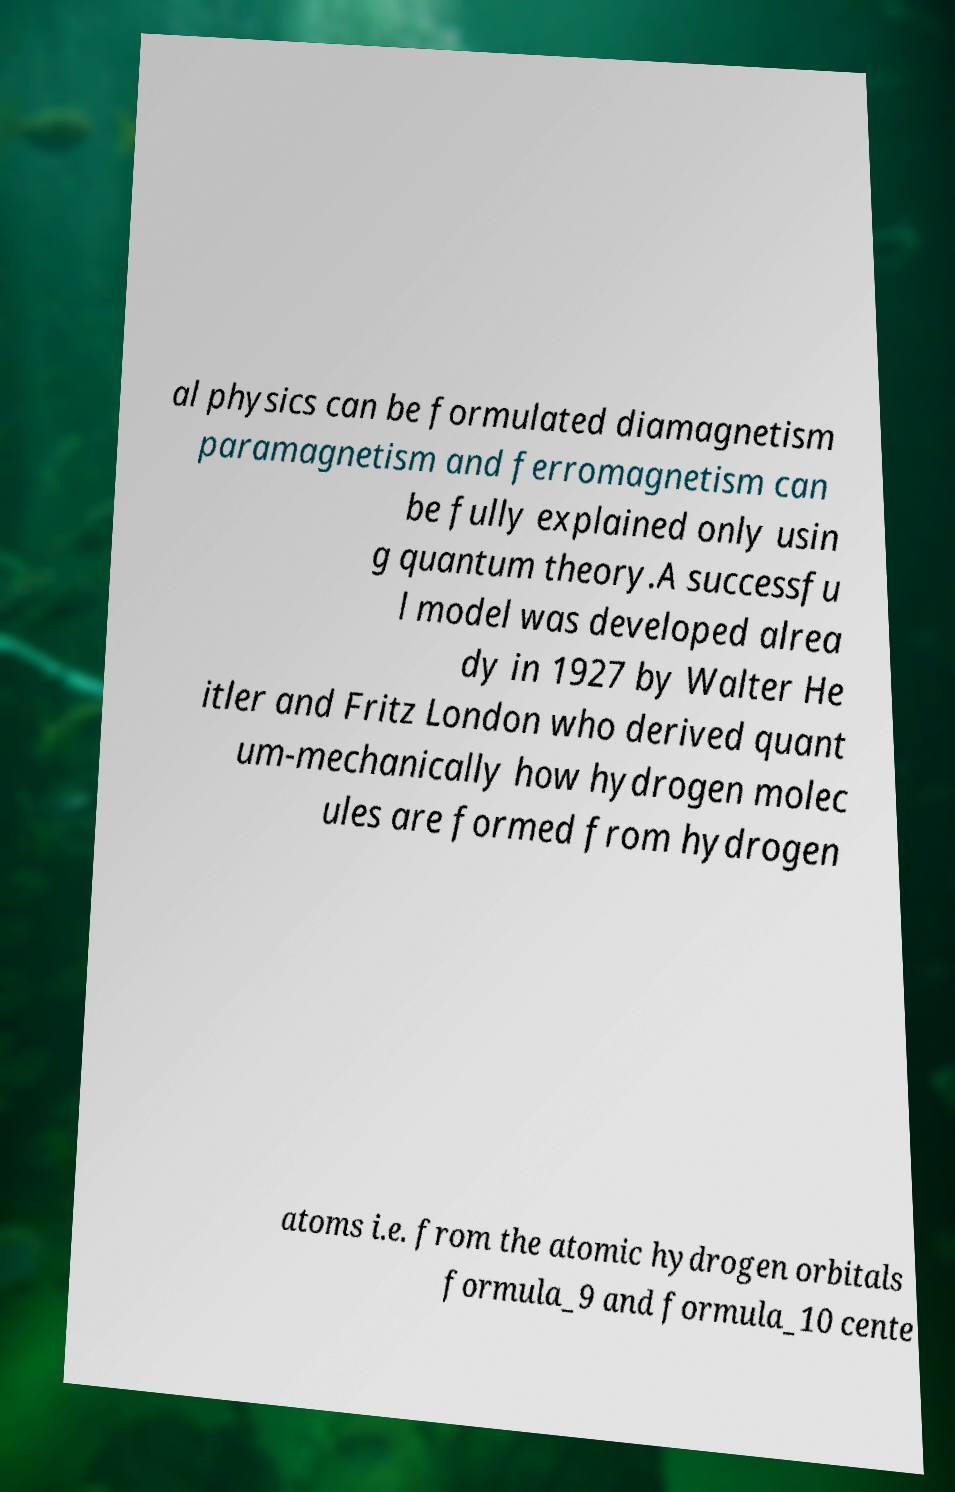Could you assist in decoding the text presented in this image and type it out clearly? al physics can be formulated diamagnetism paramagnetism and ferromagnetism can be fully explained only usin g quantum theory.A successfu l model was developed alrea dy in 1927 by Walter He itler and Fritz London who derived quant um-mechanically how hydrogen molec ules are formed from hydrogen atoms i.e. from the atomic hydrogen orbitals formula_9 and formula_10 cente 